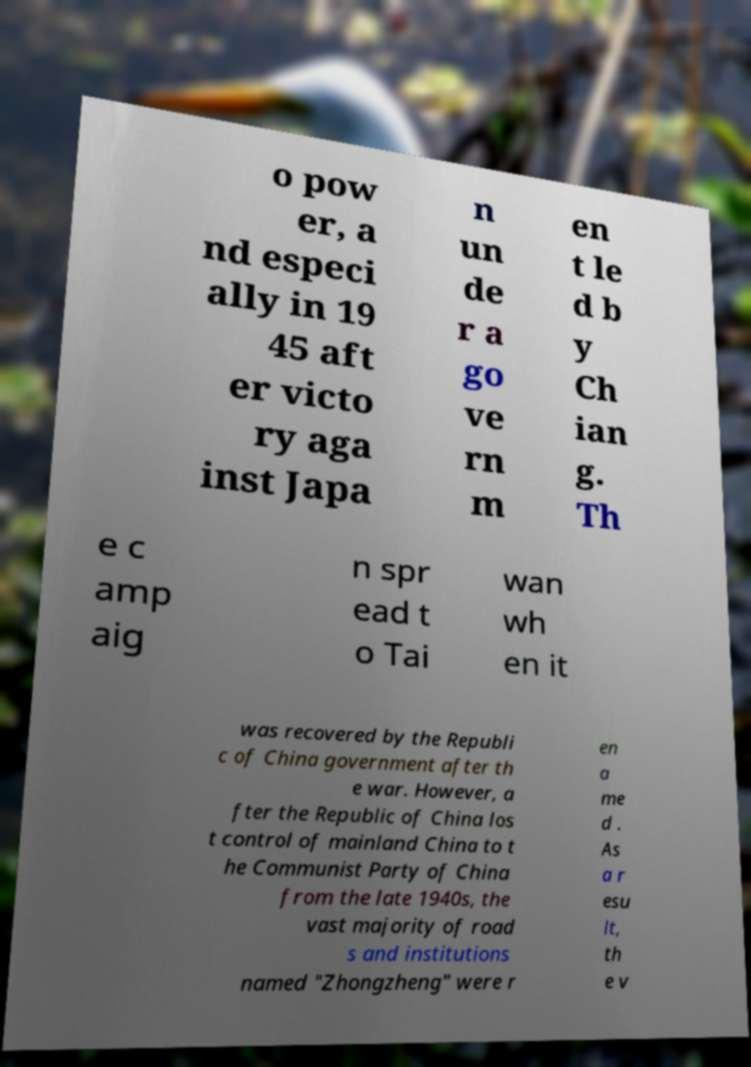Please identify and transcribe the text found in this image. o pow er, a nd especi ally in 19 45 aft er victo ry aga inst Japa n un de r a go ve rn m en t le d b y Ch ian g. Th e c amp aig n spr ead t o Tai wan wh en it was recovered by the Republi c of China government after th e war. However, a fter the Republic of China los t control of mainland China to t he Communist Party of China from the late 1940s, the vast majority of road s and institutions named "Zhongzheng" were r en a me d . As a r esu lt, th e v 